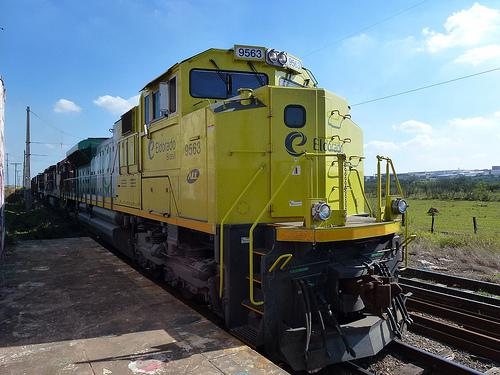Question: where is this scene taking place?
Choices:
A. At a church.
B. At the railroad tracks.
C. In an arena.
D. Under the stairs.
Answer with the letter. Answer: B Question: what kind of vehicle is in this picture?
Choices:
A. Train.
B. Van.
C. Truck.
D. Scooter.
Answer with the letter. Answer: A Question: what color is the train?
Choices:
A. Black and brown.
B. Blue and red.
C. Purple and orange.
D. Yellow and light green.
Answer with the letter. Answer: D Question: what is the train parked next to?
Choices:
A. Platform.
B. The bus.
C. The truck.
D. The van.
Answer with the letter. Answer: A Question: what are the black lines hanging above the train?
Choices:
A. Utility lines.
B. Holiday lights.
C. Power lines.
D. Tightrope wires.
Answer with the letter. Answer: C 